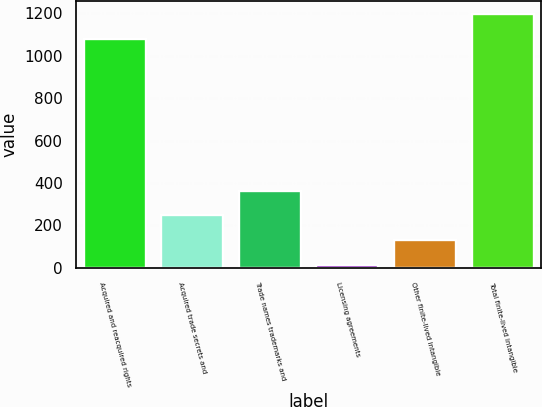Convert chart to OTSL. <chart><loc_0><loc_0><loc_500><loc_500><bar_chart><fcel>Acquired and reacquired rights<fcel>Acquired trade secrets and<fcel>Trade names trademarks and<fcel>Licensing agreements<fcel>Other finite-lived intangible<fcel>Total finite-lived intangible<nl><fcel>1081.7<fcel>247.88<fcel>364.67<fcel>14.3<fcel>131.09<fcel>1198.49<nl></chart> 